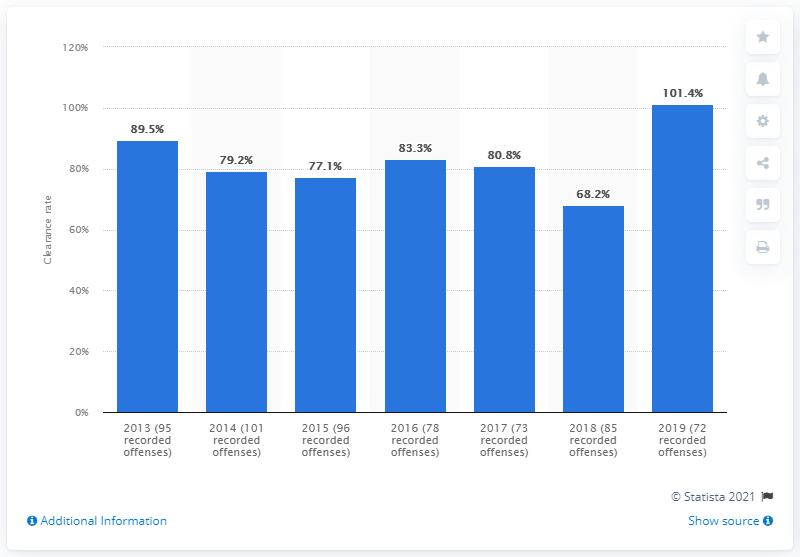Outline some significant characteristics in this image. I'm sorry, but the information you provided does not constitute a clear question or request. Could you please provide more context or clarify what you are looking for? 